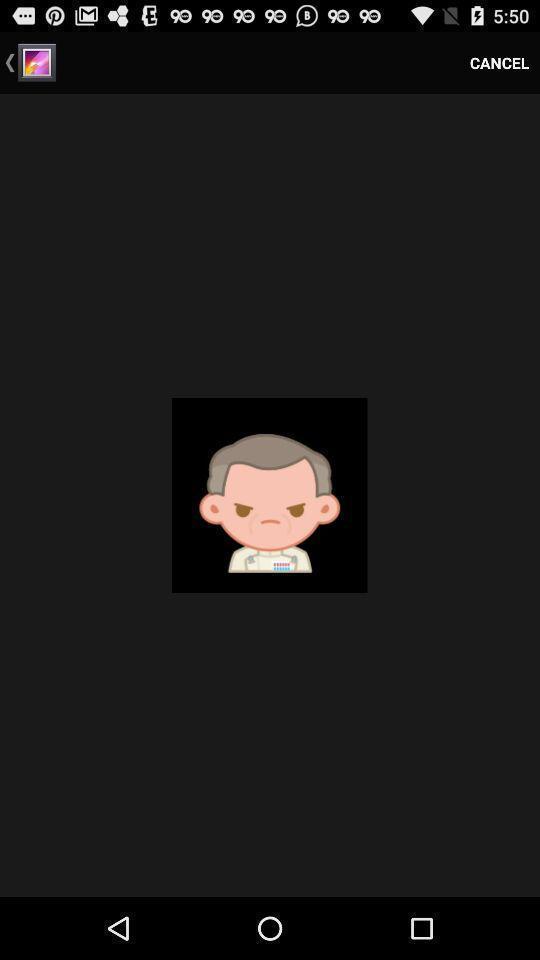Give me a narrative description of this picture. Screen displaying a picture in the gallery. 